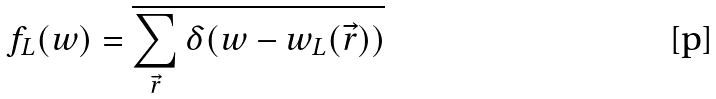Convert formula to latex. <formula><loc_0><loc_0><loc_500><loc_500>f _ { L } ( w ) = \overline { \sum _ { \vec { r } } \delta ( w - w _ { L } ( \vec { r } ) ) }</formula> 